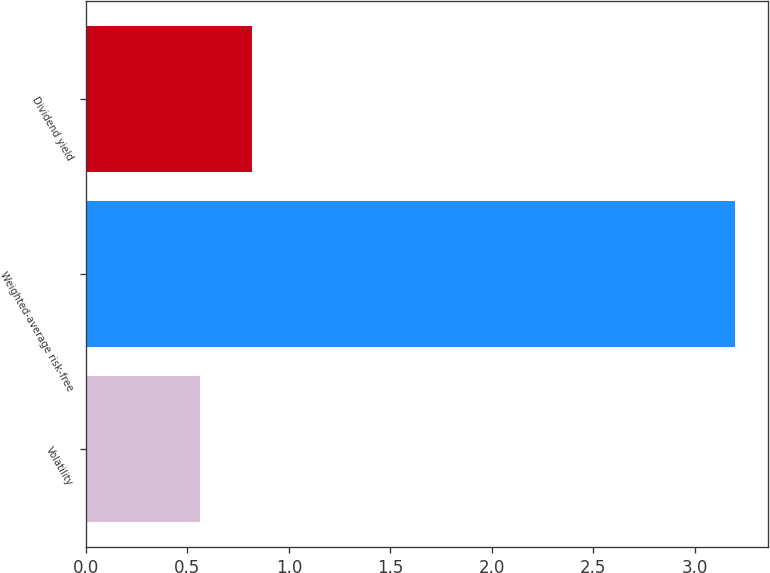Convert chart to OTSL. <chart><loc_0><loc_0><loc_500><loc_500><bar_chart><fcel>Volatility<fcel>Weighted-average risk-free<fcel>Dividend yield<nl><fcel>0.56<fcel>3.2<fcel>0.82<nl></chart> 